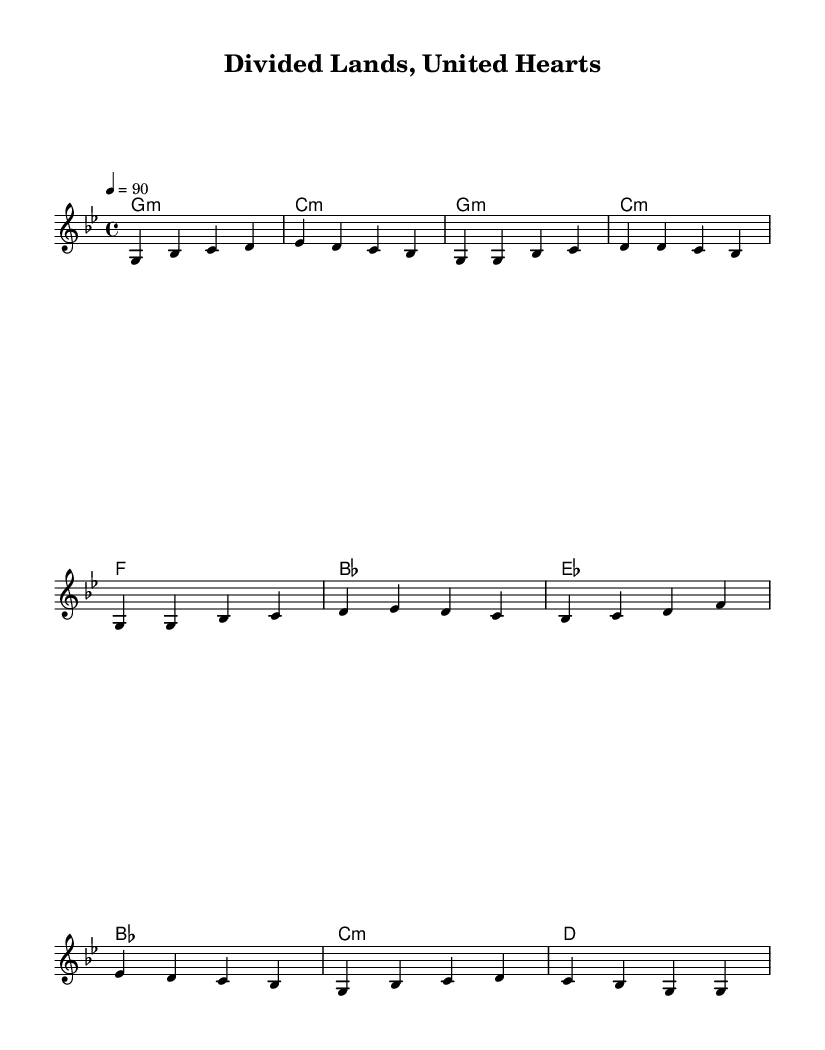What is the key signature of this music? The key signature is G minor, which is indicated by the presence of two flats (B♭ and E♭). This is Determined from the global settings listed at the beginning of the music notation.
Answer: G minor What is the time signature of this music? The time signature is 4/4, which is evident from the time signature indication provided in the global settings at the beginning of the sheet.
Answer: 4/4 What is the tempo marking for this music? The tempo marking is 90 beats per minute, as indicated by the tempo instruction "4 = 90" in the global settings.
Answer: 90 How many measures are there in the verse section? The verse section contains 4 measures, which can be counted from the melody line provided after the global settings that show the verse notation directly.
Answer: 4 What is the chord progression for the chorus? The chord progression for the chorus is E♭ - B♭ - C minor - D, based on the harmonies listed under the "Chorus" portion of the music.
Answer: E♭ - B♭ - C minor - D What type of musical composition is depicted in the sheet music? The sheet music represents a Hip Hop song with socially conscious themes, shown through the title and contextual references in the melody and harmony, which reflect deeper societal issues.
Answer: Hip Hop 